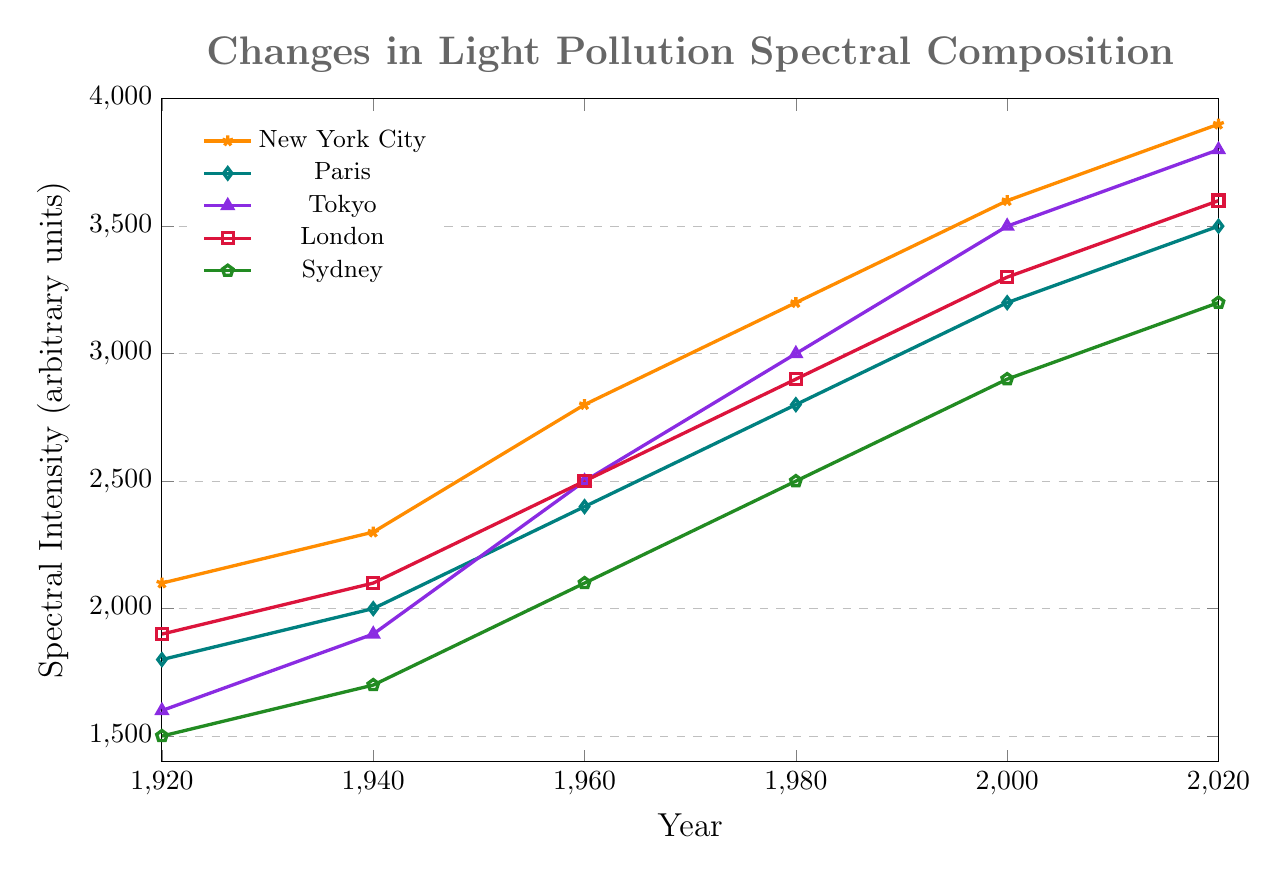1. Which city showed the largest increase in light pollution spectral intensity from 1920 to 2020? To find the answer, we subtract the intensity in 1920 from the intensity in 2020 for each city. New York City increased by 3900-2100=1800, Paris by 3500-1800=1700, Tokyo by 3800-1600=2200, London by 3600-1900=1700, and Sydney by 3200-1500=1700. The largest increase is seen in Tokyo (2200).
Answer: Tokyo 2. Compare the light pollution spectral intensity of New York City and Paris in 2000. Which city had a higher intensity? We look at the y-values for New York City and Paris in the year 2000. New York City had an intensity of 3600, while Paris had an intensity of 3200. Therefore, New York City had a higher intensity.
Answer: New York City 3. What was the average spectral intensity of light pollution in London over the entire period? To find the average, sum up London's spectral intensity values and divide by the number of data points: (1900+2100+2500+2900+3300+3600)/6 = 16200/6 = 2700.
Answer: 2700 4. Between which consecutive time periods did Sydney experience its largest increase in spectral intensity? We calculate the increase for each period: 1940-1920 = 200, 1960-1940 = 400, 1980-1960 = 400, 2000-1980 = 400, and 2020-2000 = 300. The largest increase is 400, which occurs between 1960-1980, and 1980-2000.
Answer: 1960-1980 and 1980-2000 5. Which city had the lowest spectral intensity of light pollution in 1980? Refer to the y-values for each city in the year 1980. New York City: 3200, Paris: 2800, Tokyo: 3000, London: 2900, Sydney: 2500. The lowest value is for Sydney.
Answer: Sydney 6. By how much did the spectral intensity of light pollution increase in New York City from 1960 to 2000? Subtract the intensity in 1960 from the intensity in 2000 for New York City: 3600-2800=800.
Answer: 800 7. What's the median spectral intensity of Paris over the recorded years? To find the median, list the values in ascending order: 1800, 2000, 2400, 2800, 3200, 3500. The median is the average of the two middle values: (2400+2800)/2 = 2600.
Answer: 2600 8. How does the spectral intensity trend of Tokyo compare to that of Sydney from 1920 to 2020? Tokyo's intensity values increased significantly from 1600 to 3800, while Sydney's values increased from 1500 to 3200. Tokyo shows a steeper increase overall compared to Sydney.
Answer: Tokyo increased more 9. If you were to visualize the intensity changes of all cities starting from the year 1960, which city shows the most dramatic rate of increase by 2020? Calculate the rate of increase from 1960 to 2020: New York City: (3900-2800)=1100, Paris: (3500-2400)=1100, Tokyo: (3800-2500)=1300, London: (3600-2500)=1100, Sydney: (3200-2100)=1100. Tokyo shows the most dramatic increase.
Answer: Tokyo 10. What is the combined spectral intensity of New York City and London in 2020? Add the spectral intensity values for New York City and London in 2020: 3900 + 3600 = 7500.
Answer: 7500 